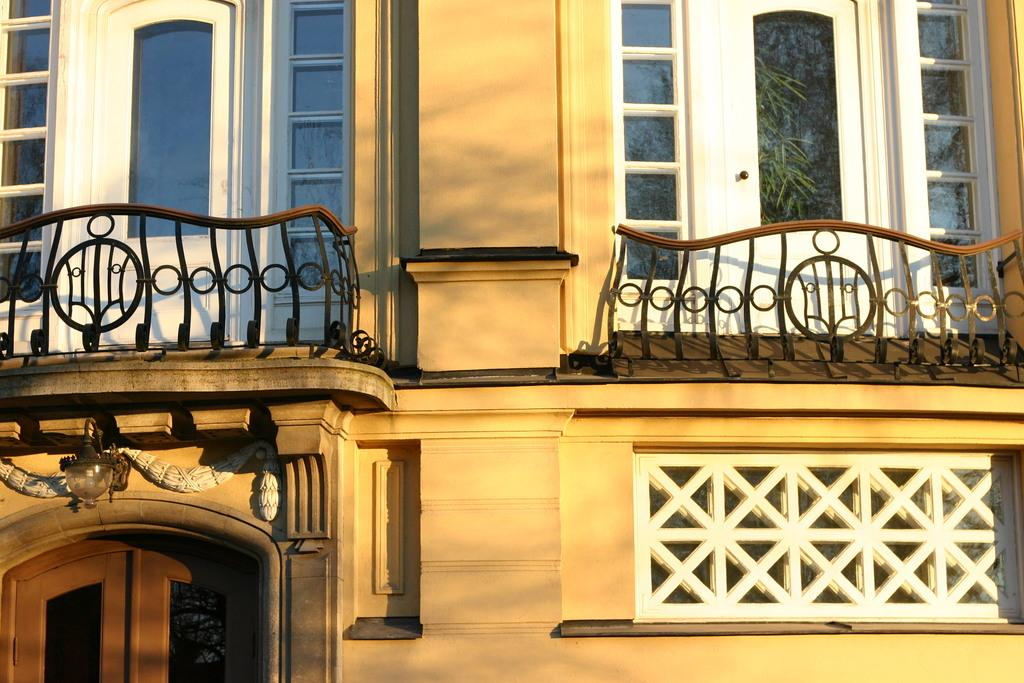What is the color of the building in the image? The building in the image is cream-colored. How many balconies are on the building? The building has two balconies. What type of doors are present in the image? There are two white doors with glass panels and a main brown-colored door in the image. Where is the light located in the image? The light is attached to the wall above the door. Can you see any pigs on the hill in the image? There is no hill or pigs present in the image; it features a cream-colored building with doors and a light. 